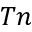Convert formula to latex. <formula><loc_0><loc_0><loc_500><loc_500>T n</formula> 